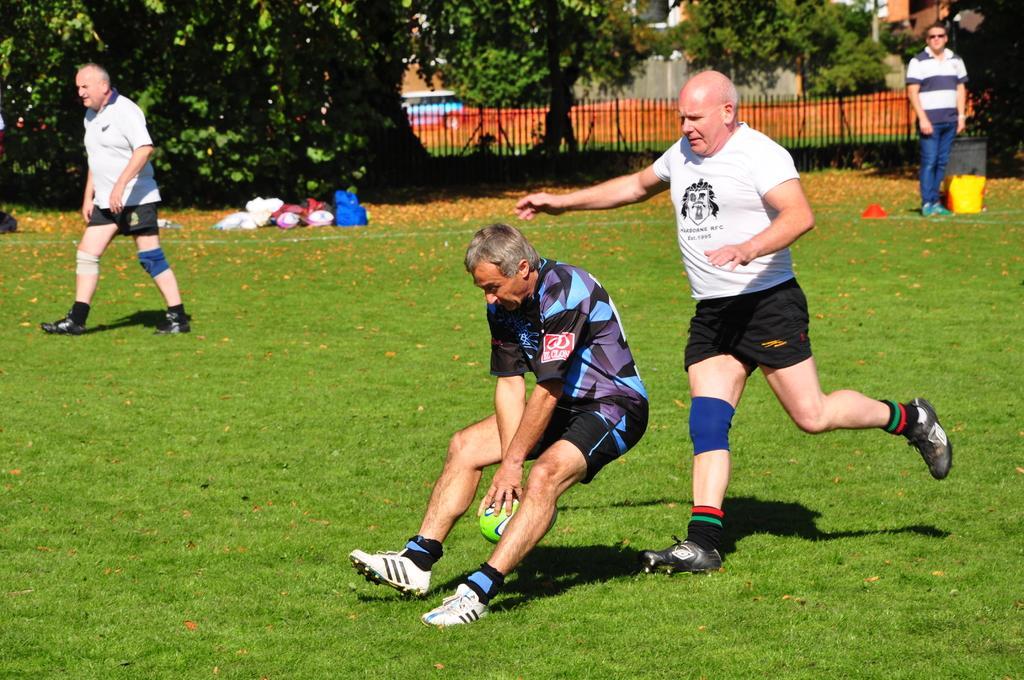Describe this image in one or two sentences. There are old men in the ground, playing a sport with a ball. In the background there is a man standing and watching these members. There are some trees and railing here. In front of trees there are some luggage bags. 